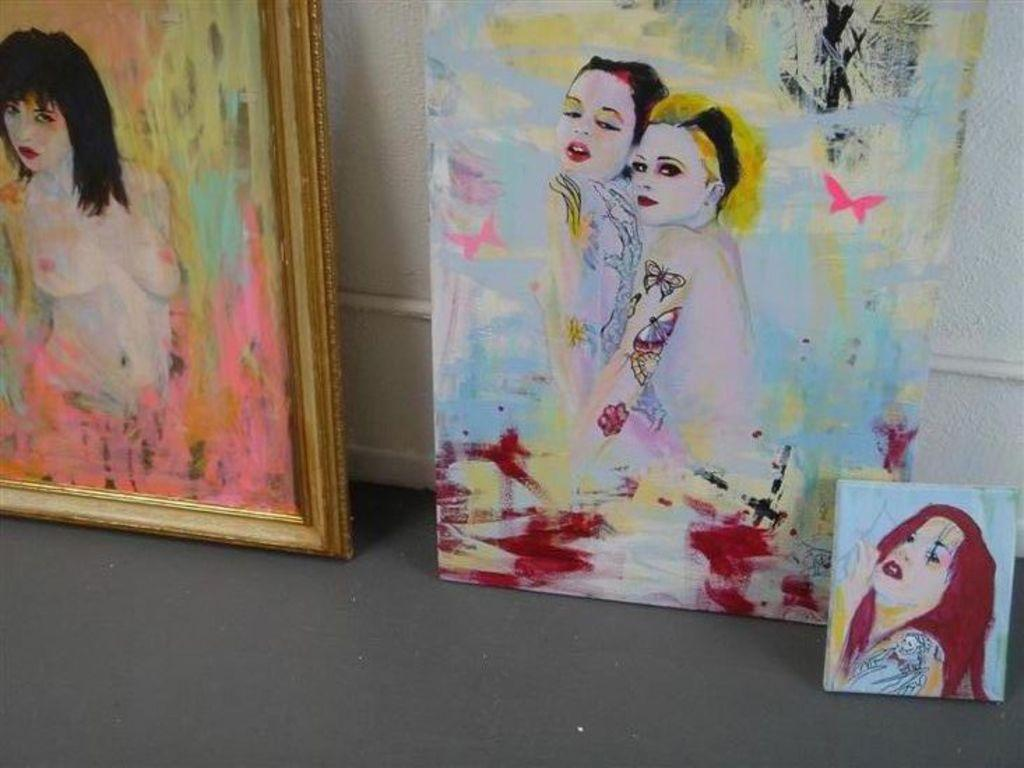What is the color of the wall in the image? The wall in the image is white. What is hung on the wall? There are frames on the wall. What can be seen inside the frames? There are people depicted in the frames. Can you see any grass growing on the wall in the image? No, there is no grass growing on the wall in the image. 